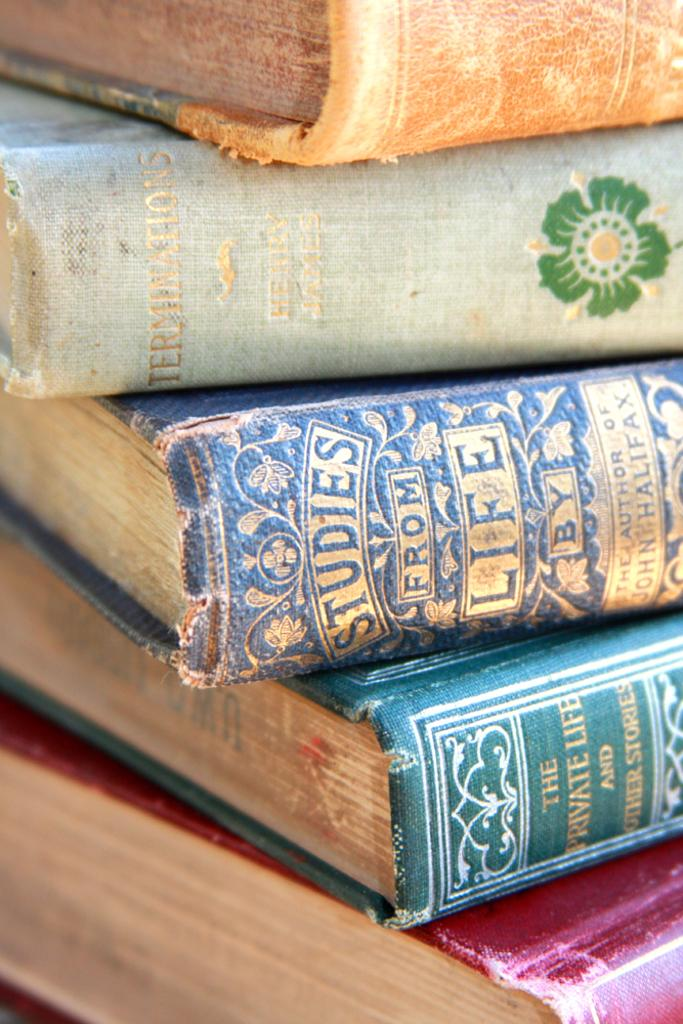<image>
Relay a brief, clear account of the picture shown. a book called 'studies from life' in a stack of books 